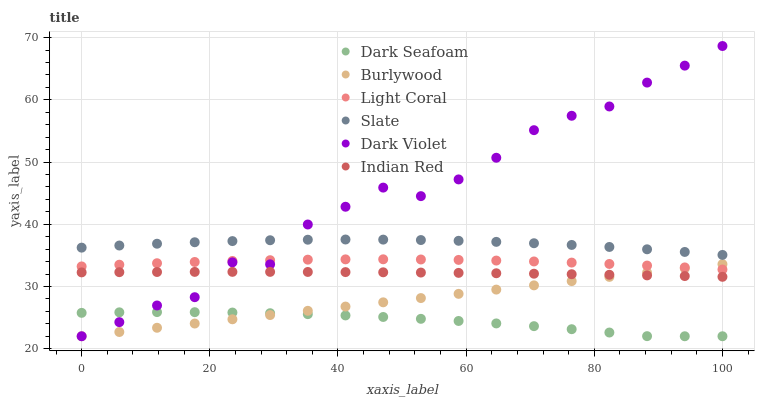Does Dark Seafoam have the minimum area under the curve?
Answer yes or no. Yes. Does Dark Violet have the maximum area under the curve?
Answer yes or no. Yes. Does Slate have the minimum area under the curve?
Answer yes or no. No. Does Slate have the maximum area under the curve?
Answer yes or no. No. Is Burlywood the smoothest?
Answer yes or no. Yes. Is Dark Violet the roughest?
Answer yes or no. Yes. Is Slate the smoothest?
Answer yes or no. No. Is Slate the roughest?
Answer yes or no. No. Does Burlywood have the lowest value?
Answer yes or no. Yes. Does Slate have the lowest value?
Answer yes or no. No. Does Dark Violet have the highest value?
Answer yes or no. Yes. Does Slate have the highest value?
Answer yes or no. No. Is Light Coral less than Slate?
Answer yes or no. Yes. Is Slate greater than Indian Red?
Answer yes or no. Yes. Does Dark Violet intersect Dark Seafoam?
Answer yes or no. Yes. Is Dark Violet less than Dark Seafoam?
Answer yes or no. No. Is Dark Violet greater than Dark Seafoam?
Answer yes or no. No. Does Light Coral intersect Slate?
Answer yes or no. No. 